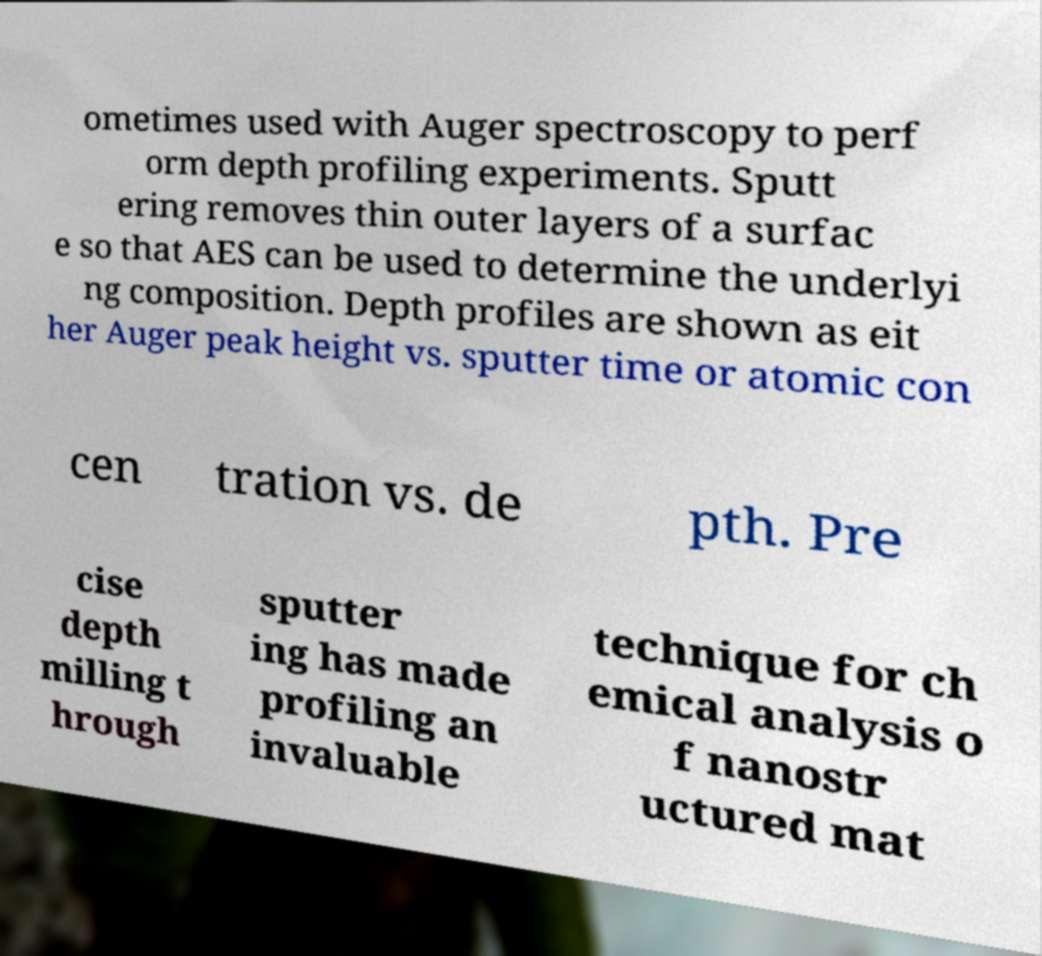Could you extract and type out the text from this image? ometimes used with Auger spectroscopy to perf orm depth profiling experiments. Sputt ering removes thin outer layers of a surfac e so that AES can be used to determine the underlyi ng composition. Depth profiles are shown as eit her Auger peak height vs. sputter time or atomic con cen tration vs. de pth. Pre cise depth milling t hrough sputter ing has made profiling an invaluable technique for ch emical analysis o f nanostr uctured mat 